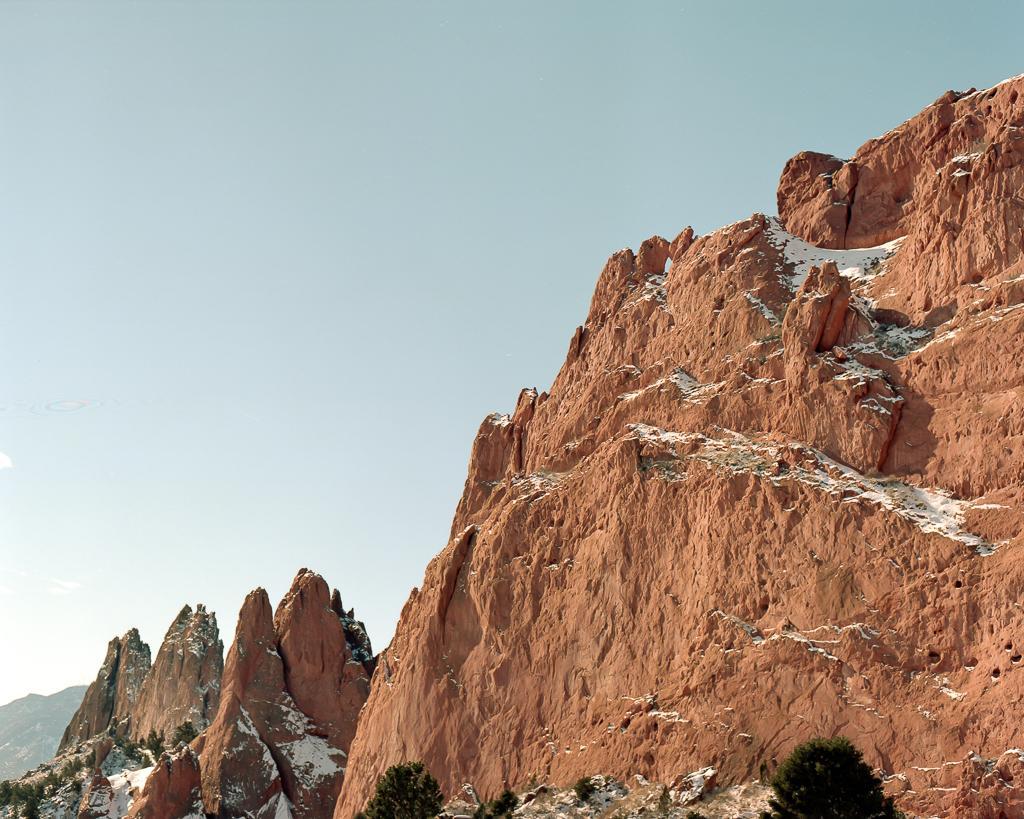Describe this image in one or two sentences. In this at front there are plants and snow on the mountains. At the background there is sky. 